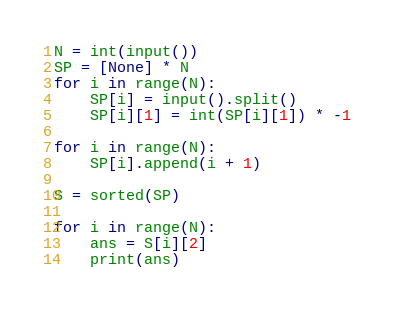Convert code to text. <code><loc_0><loc_0><loc_500><loc_500><_Python_>N = int(input())
SP = [None] * N
for i in range(N):
    SP[i] = input().split()
    SP[i][1] = int(SP[i][1]) * -1

for i in range(N):
    SP[i].append(i + 1)

S = sorted(SP)

for i in range(N):
    ans = S[i][2]
    print(ans)</code> 